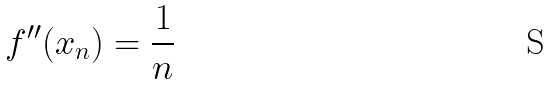Convert formula to latex. <formula><loc_0><loc_0><loc_500><loc_500>f ^ { \prime \prime } ( x _ { n } ) = \frac { 1 } { n }</formula> 